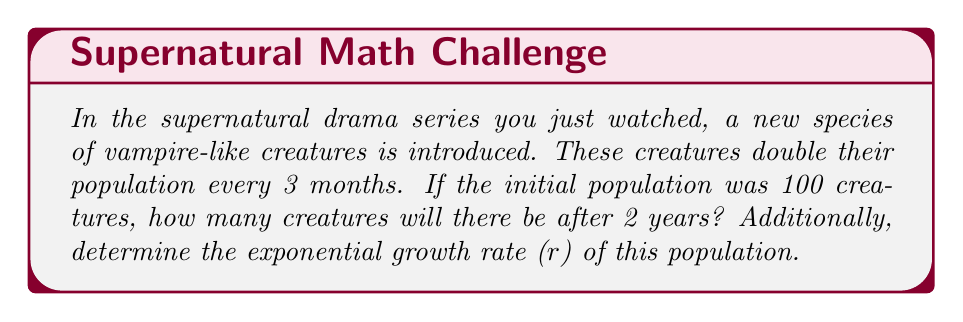Can you solve this math problem? Let's approach this problem step by step:

1) First, we need to identify the key information:
   - Initial population (P₀) = 100
   - Population doubles every 3 months
   - Time period (t) = 2 years = 24 months = 8 doubling periods

2) We can use the exponential growth formula:
   $$ P(t) = P_0 \cdot 2^n $$
   Where n is the number of doubling periods.

3) In this case:
   $$ P(8) = 100 \cdot 2^8 = 100 \cdot 256 = 25,600 $$

4) To find the exponential growth rate (r), we can use the general exponential growth formula:
   $$ P(t) = P_0 \cdot e^{rt} $$

5) We know that the population doubles every 3 months, so:
   $$ 2P_0 = P_0 \cdot e^{r(3/12)} $$

6) Simplify:
   $$ 2 = e^{r(1/4)} $$

7) Take the natural log of both sides:
   $$ \ln(2) = r(1/4) $$

8) Solve for r:
   $$ r = 4\ln(2) \approx 2.77 $$

This means the population grows at a rate of about 277% per year.
Answer: After 2 years, there will be 25,600 creatures. The exponential growth rate (r) is approximately 2.77 or 277% per year. 